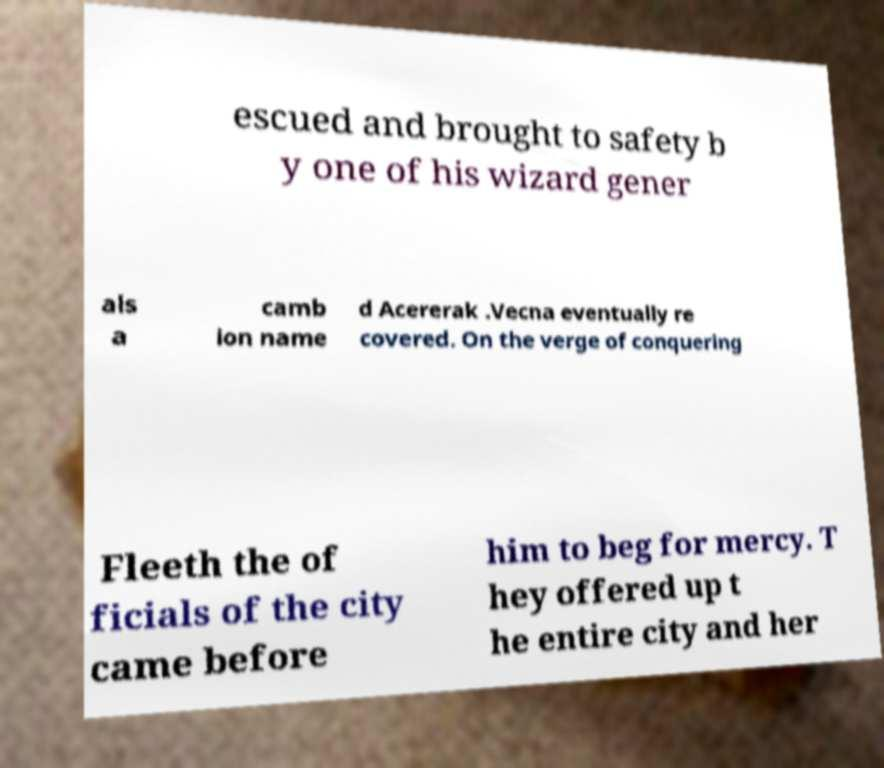There's text embedded in this image that I need extracted. Can you transcribe it verbatim? escued and brought to safety b y one of his wizard gener als a camb ion name d Acererak .Vecna eventually re covered. On the verge of conquering Fleeth the of ficials of the city came before him to beg for mercy. T hey offered up t he entire city and her 